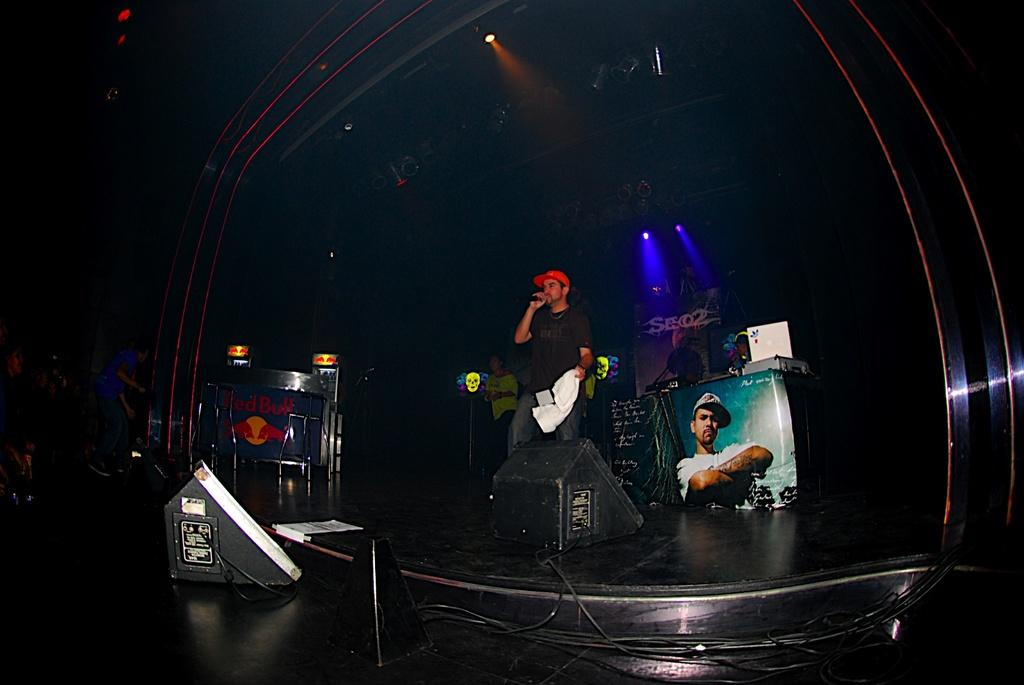What is the person in the image doing? The person is standing in the image and holding a microphone. What is the person wearing on their head? The person is wearing a wire cap. What can be seen on the floor in the image? There are devices and cables visible on the floor. What is visible in the background of the image? The background of the image includes people, a banner, and lights. What type of tomatoes are being used as a prop in the image? There are no tomatoes present in the image. Can you tell me how many veins are visible on the person's arm in the image? The image does not show the person's arm or any veins. 